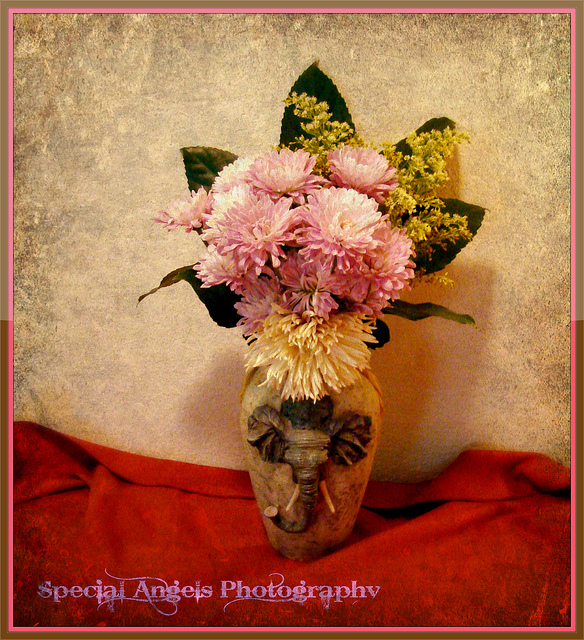<image>What animal is represented in the photo? I'm not sure about the animal represented in the photo, it can either be an elephant or a butterfly. What animal is represented in the photo? I don't know what animal is represented in the photo. But it can be seen an elephant. 